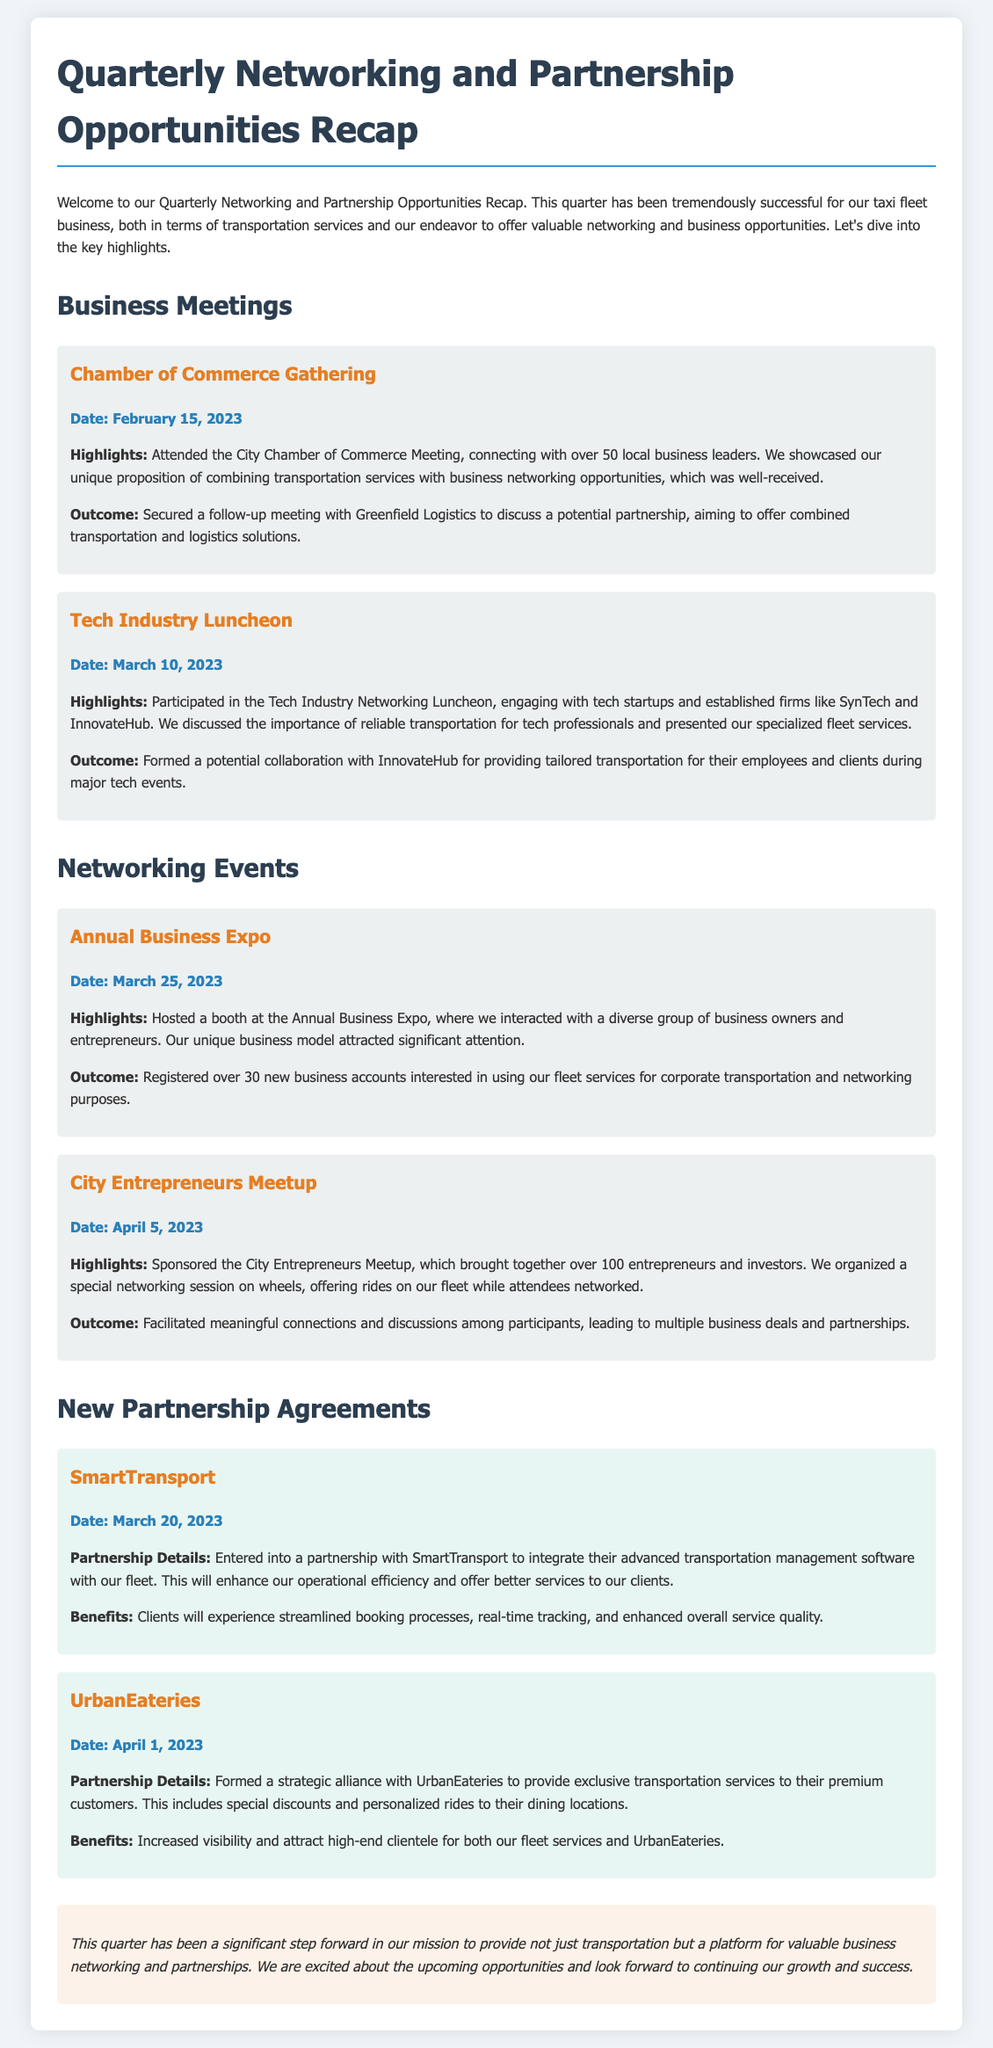What was the date of the Chamber of Commerce Gathering? The date is explicitly mentioned in the document under the event section for the Chamber of Commerce Gathering.
Answer: February 15, 2023 Who did we secure a follow-up meeting with? The document lists the outcome of the Chamber of Commerce Gathering, specifying who the follow-up meeting was with.
Answer: Greenfield Logistics How many new business accounts were registered at the Annual Business Expo? The document highlights the outcome of the Annual Business Expo, indicating the number of new business accounts registered.
Answer: Over 30 What is the name of the software company we partnered with? The name of the company is provided in the section on new partnership agreements, specifically under SmartTransport.
Answer: SmartTransport What unique proposition did we showcase at the Chamber of Commerce Gathering? The document mentions the unique proposition we showcased during the meeting with local business leaders.
Answer: Combining transportation services with business networking opportunities How many entrepreneurs and investors attended the City Entrepreneurs Meetup? The attendance of the City Entrepreneurs Meetup is mentioned in the event highlights, indicating the number of attendees.
Answer: Over 100 What type of clients will benefit from the partnership with UrbanEateries? The document specifies the clientele that will benefit from the partnership with UrbanEateries under the partnership details.
Answer: Premium customers Which event included a special networking session on wheels? The document describes an event that featured a unique networking format, mentioned in the corresponding section.
Answer: City Entrepreneurs Meetup 